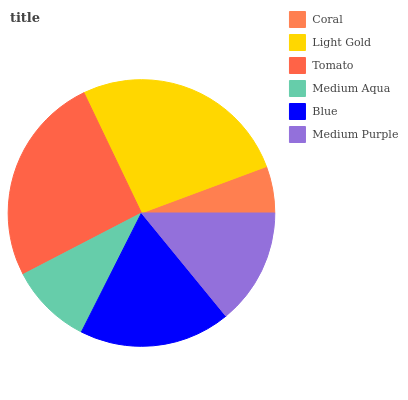Is Coral the minimum?
Answer yes or no. Yes. Is Light Gold the maximum?
Answer yes or no. Yes. Is Tomato the minimum?
Answer yes or no. No. Is Tomato the maximum?
Answer yes or no. No. Is Light Gold greater than Tomato?
Answer yes or no. Yes. Is Tomato less than Light Gold?
Answer yes or no. Yes. Is Tomato greater than Light Gold?
Answer yes or no. No. Is Light Gold less than Tomato?
Answer yes or no. No. Is Blue the high median?
Answer yes or no. Yes. Is Medium Purple the low median?
Answer yes or no. Yes. Is Light Gold the high median?
Answer yes or no. No. Is Blue the low median?
Answer yes or no. No. 